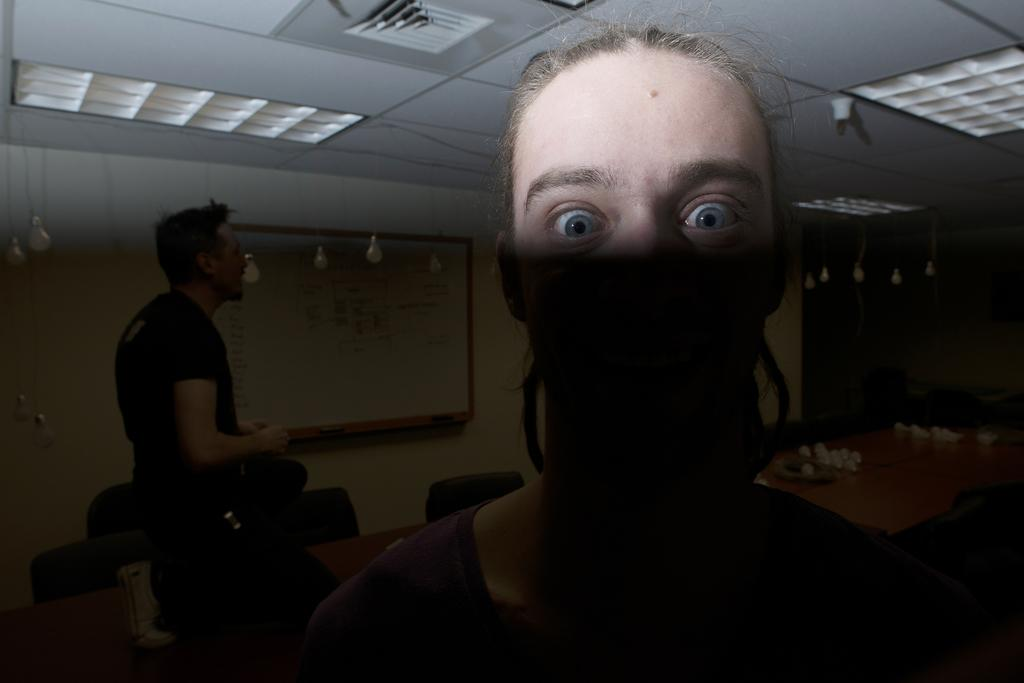What is the main subject of the image? There is a woman standing in the image. Can you describe the setting of the image? There is a table, chairs, and a wall in the image. Is there anyone else in the image besides the woman? Yes, there is a person standing in the background of the image. What is on the wall in the image? There is a board on the wall. What type of lighting is present in the image? There are lights in the image. What type of stem can be seen growing from the floor in the image? There is no stem growing from the floor in the image. What type of farm animals can be seen in the image? There are no farm animals present in the image. 